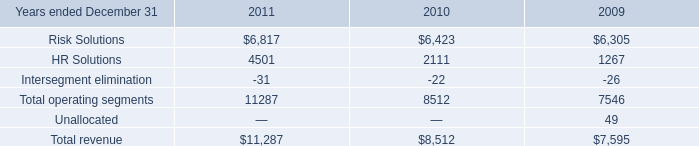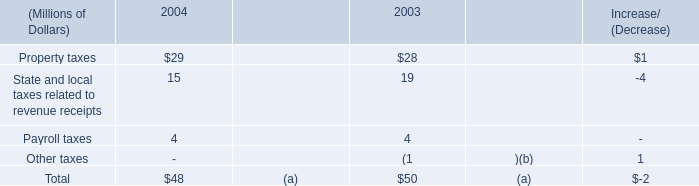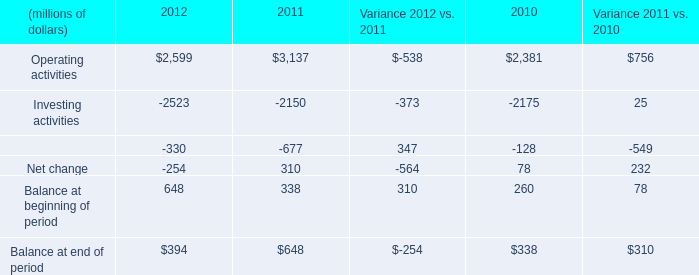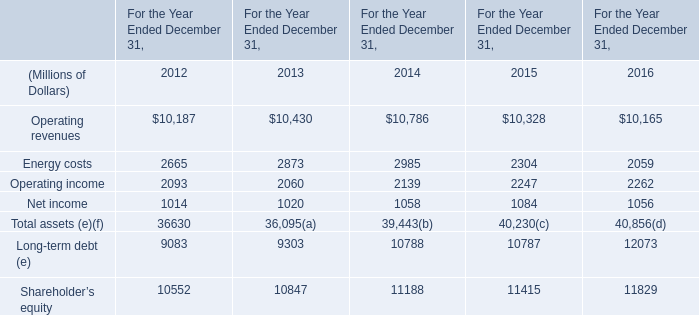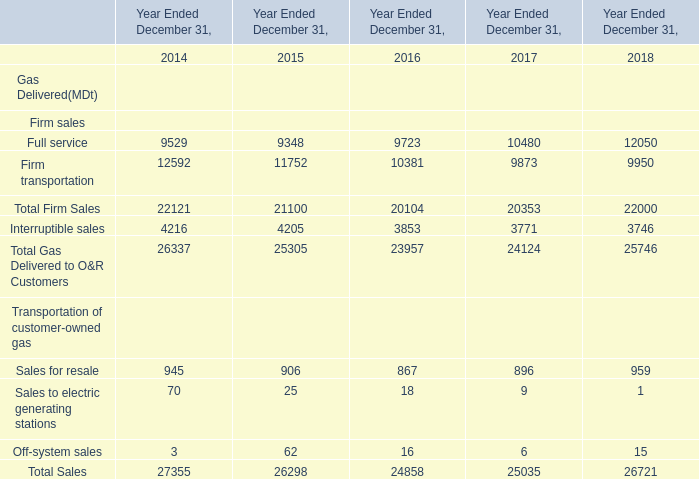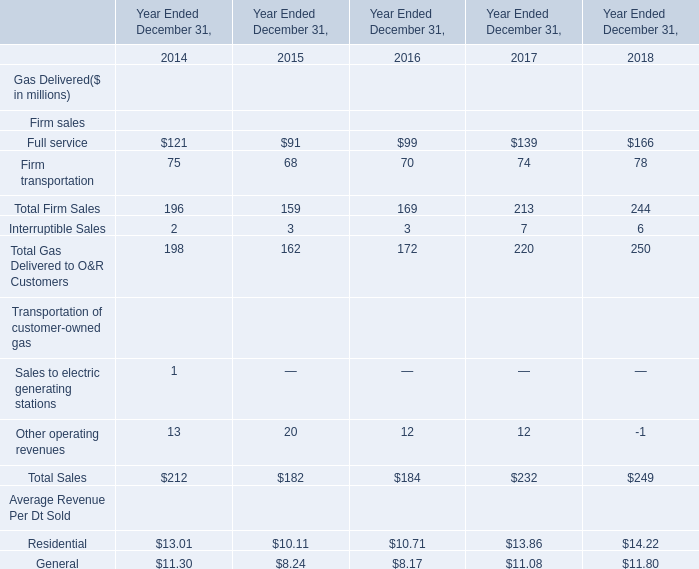what was the percent of the increase in the aons revenues for risk solutions from 2010 to 2011 
Computations: ((6817 - 6423) / 6423)
Answer: 0.06134. 